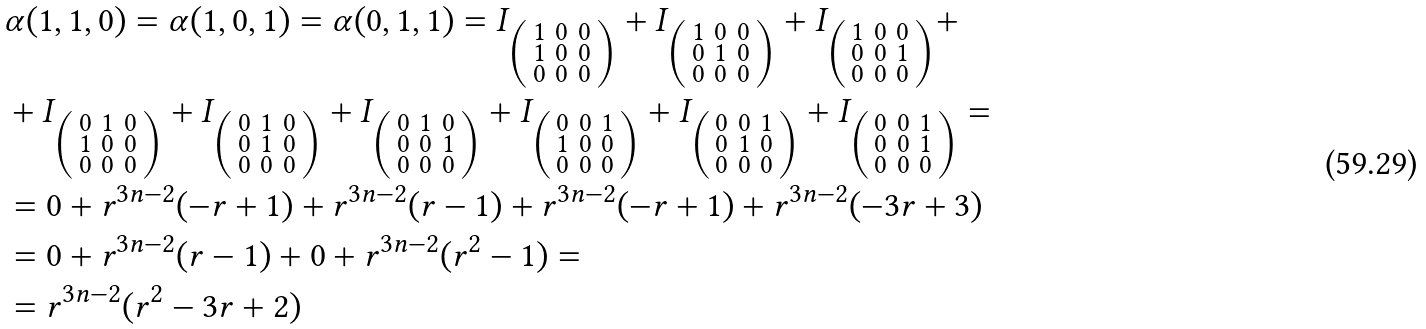Convert formula to latex. <formula><loc_0><loc_0><loc_500><loc_500>& \alpha ( 1 , 1 , 0 ) = \alpha ( 1 , 0 , 1 ) = \alpha ( 0 , 1 , 1 ) = I _ { \left ( \begin{smallmatrix} 1 & 0 & 0 \\ 1 & 0 & 0 \\ 0 & 0 & 0 \end{smallmatrix} \right ) } + I _ { \left ( \begin{smallmatrix} 1 & 0 & 0 \\ 0 & 1 & 0 \\ 0 & 0 & 0 \end{smallmatrix} \right ) } + I _ { \left ( \begin{smallmatrix} 1 & 0 & 0 \\ 0 & 0 & 1 \\ 0 & 0 & 0 \end{smallmatrix} \right ) } + \\ & + I _ { \left ( \begin{smallmatrix} 0 & 1 & 0 \\ 1 & 0 & 0 \\ 0 & 0 & 0 \end{smallmatrix} \right ) } + I _ { \left ( \begin{smallmatrix} 0 & 1 & 0 \\ 0 & 1 & 0 \\ 0 & 0 & 0 \end{smallmatrix} \right ) } + I _ { \left ( \begin{smallmatrix} 0 & 1 & 0 \\ 0 & 0 & 1 \\ 0 & 0 & 0 \end{smallmatrix} \right ) } + I _ { \left ( \begin{smallmatrix} 0 & 0 & 1 \\ 1 & 0 & 0 \\ 0 & 0 & 0 \end{smallmatrix} \right ) } + I _ { \left ( \begin{smallmatrix} 0 & 0 & 1 \\ 0 & 1 & 0 \\ 0 & 0 & 0 \end{smallmatrix} \right ) } + I _ { \left ( \begin{smallmatrix} 0 & 0 & 1 \\ 0 & 0 & 1 \\ 0 & 0 & 0 \end{smallmatrix} \right ) } = \\ & = 0 + r ^ { 3 n - 2 } ( - r + 1 ) + r ^ { 3 n - 2 } ( r - 1 ) + r ^ { 3 n - 2 } ( - r + 1 ) + r ^ { 3 n - 2 } ( - 3 r + 3 ) \\ & = 0 + r ^ { 3 n - 2 } ( r - 1 ) + 0 + r ^ { 3 n - 2 } ( r ^ { 2 } - 1 ) = \\ & = r ^ { 3 n - 2 } ( r ^ { 2 } - 3 r + 2 )</formula> 